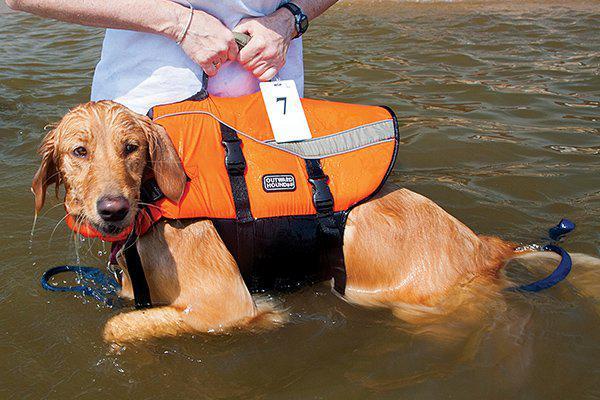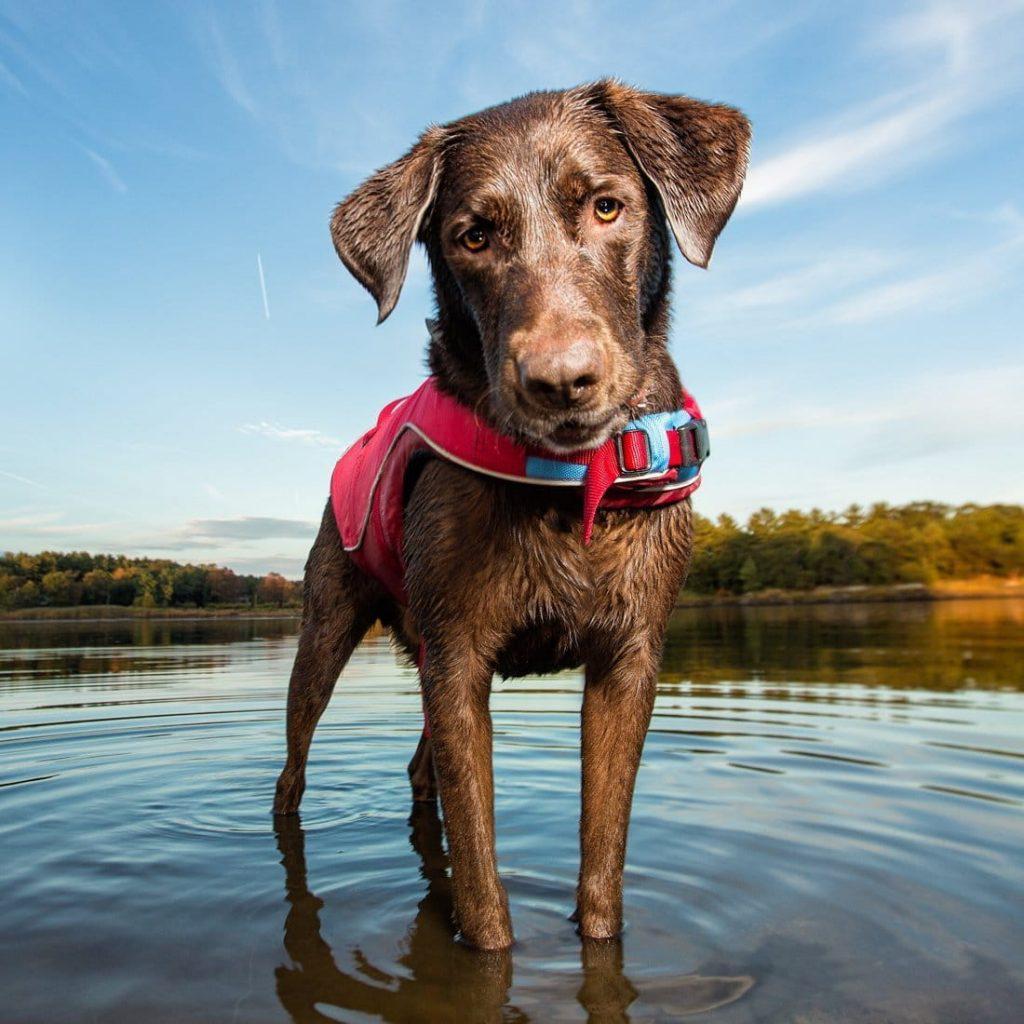The first image is the image on the left, the second image is the image on the right. For the images displayed, is the sentence "In at least one image, a dog is in a body of water while wearing a life jacket or flotation device of some kind" factually correct? Answer yes or no. Yes. The first image is the image on the left, the second image is the image on the right. Analyze the images presented: Is the assertion "The left image contains one dog that is black." valid? Answer yes or no. No. 